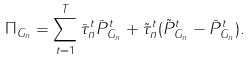<formula> <loc_0><loc_0><loc_500><loc_500>\Pi _ { G _ { n } } = \sum _ { t = 1 } ^ { T } \bar { \tau } _ { n } ^ { t } \bar { P } _ { G _ { n } } ^ { t } + \tilde { \tau } _ { n } ^ { t } ( \tilde { P } _ { G _ { n } } ^ { t } - \bar { P } _ { G _ { n } } ^ { t } ) .</formula> 